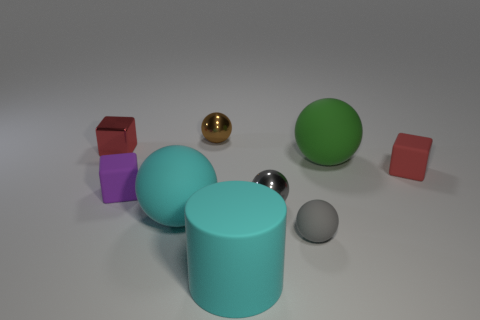Subtract 2 spheres. How many spheres are left? 3 Subtract all tiny gray metal spheres. How many spheres are left? 4 Subtract all green spheres. How many spheres are left? 4 Add 1 small cyan blocks. How many objects exist? 10 Subtract all purple spheres. Subtract all purple cylinders. How many spheres are left? 5 Subtract all cylinders. How many objects are left? 8 Add 6 small shiny things. How many small shiny things are left? 9 Add 9 metal cubes. How many metal cubes exist? 10 Subtract 0 blue balls. How many objects are left? 9 Subtract all rubber cubes. Subtract all rubber cubes. How many objects are left? 5 